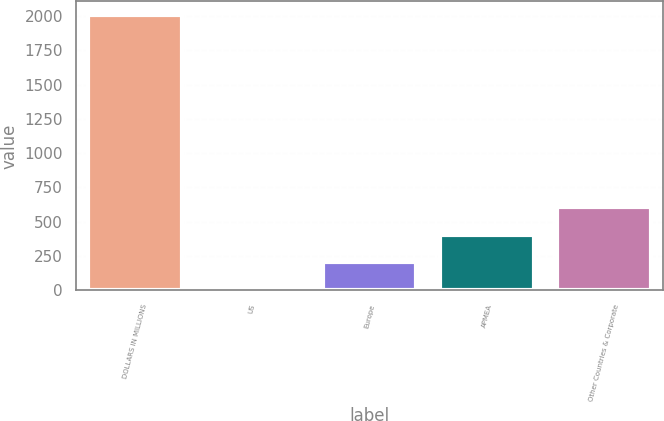Convert chart. <chart><loc_0><loc_0><loc_500><loc_500><bar_chart><fcel>DOLLARS IN MILLIONS<fcel>US<fcel>Europe<fcel>APMEA<fcel>Other Countries & Corporate<nl><fcel>2006<fcel>4<fcel>204.2<fcel>404.4<fcel>604.6<nl></chart> 